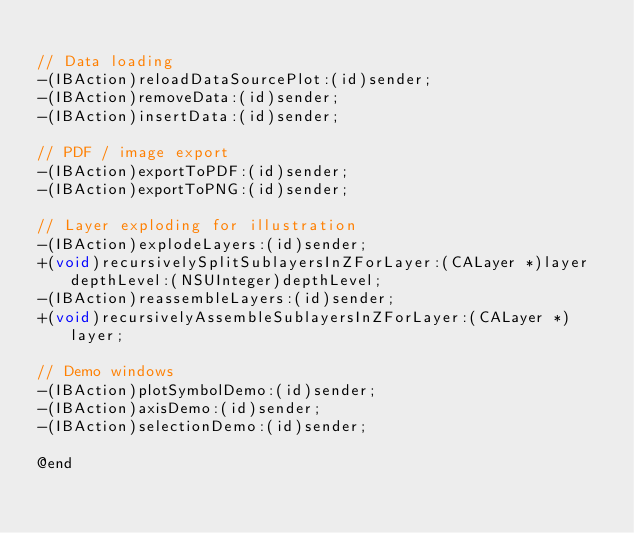<code> <loc_0><loc_0><loc_500><loc_500><_C_>
// Data loading
-(IBAction)reloadDataSourcePlot:(id)sender;
-(IBAction)removeData:(id)sender;
-(IBAction)insertData:(id)sender;

// PDF / image export
-(IBAction)exportToPDF:(id)sender;
-(IBAction)exportToPNG:(id)sender;

// Layer exploding for illustration
-(IBAction)explodeLayers:(id)sender;
+(void)recursivelySplitSublayersInZForLayer:(CALayer *)layer depthLevel:(NSUInteger)depthLevel;
-(IBAction)reassembleLayers:(id)sender;
+(void)recursivelyAssembleSublayersInZForLayer:(CALayer *)layer;

// Demo windows
-(IBAction)plotSymbolDemo:(id)sender;
-(IBAction)axisDemo:(id)sender;
-(IBAction)selectionDemo:(id)sender;

@end
</code> 